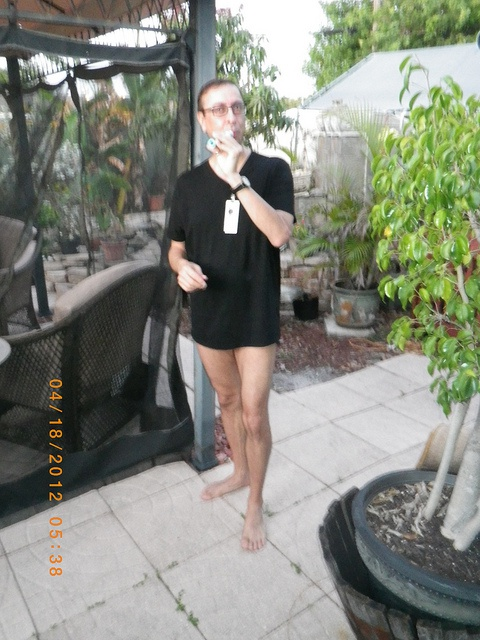Describe the objects in this image and their specific colors. I can see potted plant in brown, gray, olive, darkgray, and black tones, people in brown, black, tan, lightgray, and darkgray tones, chair in brown, black, gray, and darkgray tones, potted plant in brown, gray, darkgreen, and darkgray tones, and chair in brown, gray, black, and darkgray tones in this image. 